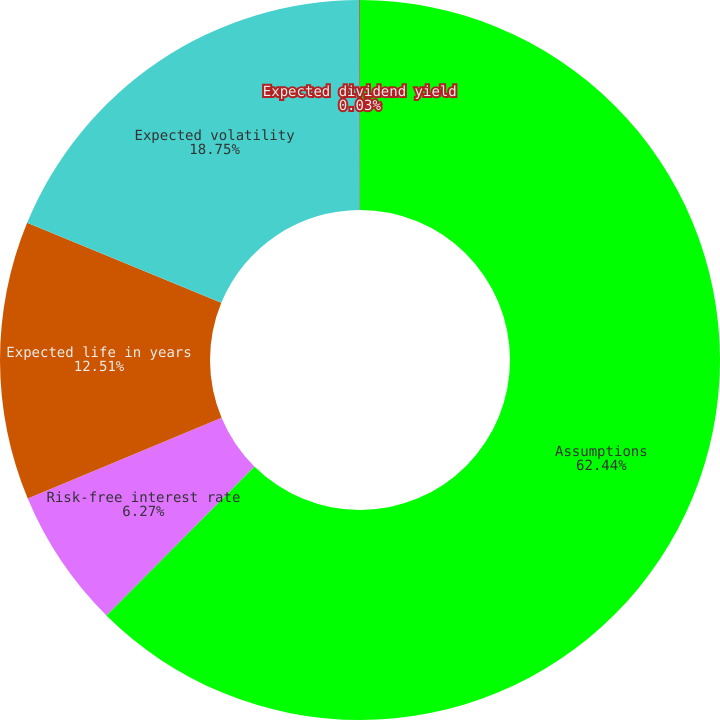Convert chart. <chart><loc_0><loc_0><loc_500><loc_500><pie_chart><fcel>Assumptions<fcel>Risk-free interest rate<fcel>Expected life in years<fcel>Expected volatility<fcel>Expected dividend yield<nl><fcel>62.44%<fcel>6.27%<fcel>12.51%<fcel>18.75%<fcel>0.03%<nl></chart> 